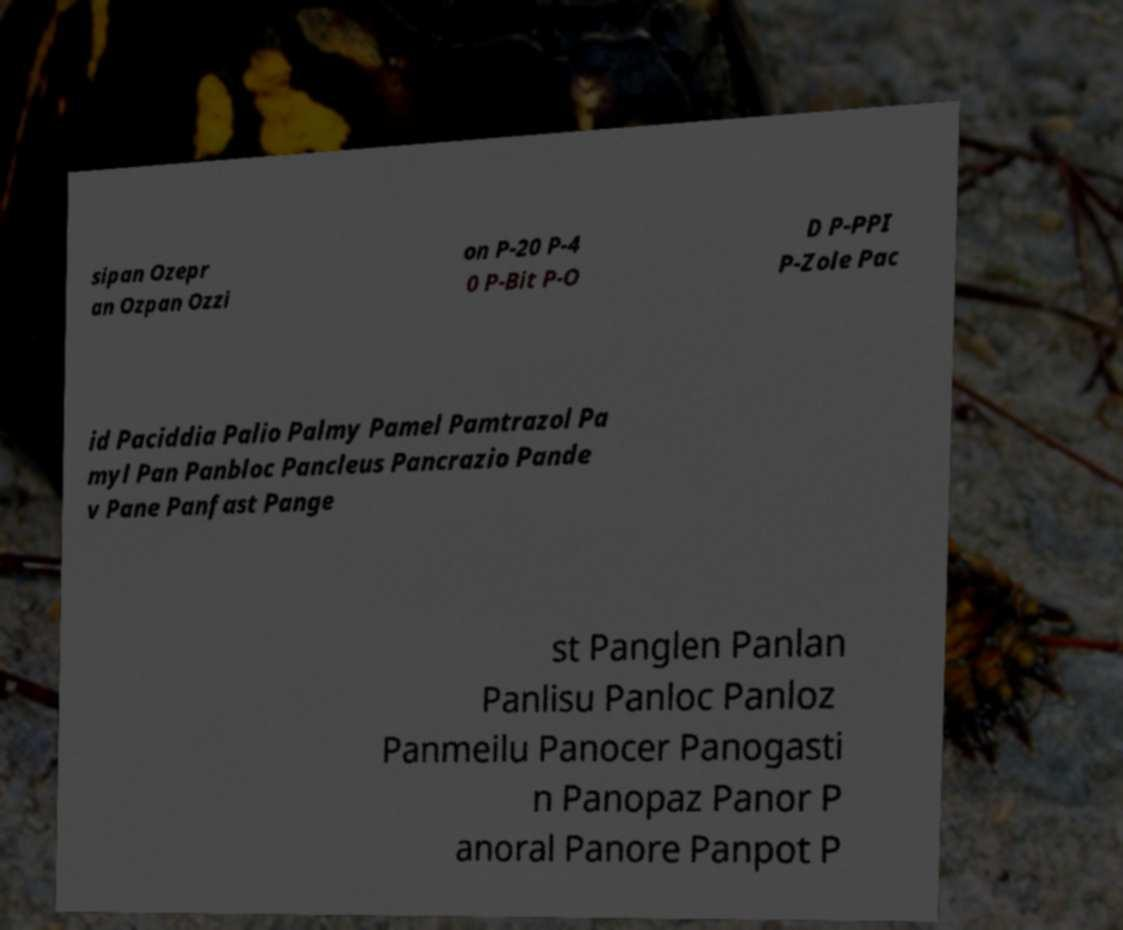Please identify and transcribe the text found in this image. sipan Ozepr an Ozpan Ozzi on P-20 P-4 0 P-Bit P-O D P-PPI P-Zole Pac id Paciddia Palio Palmy Pamel Pamtrazol Pa myl Pan Panbloc Pancleus Pancrazio Pande v Pane Panfast Pange st Panglen Panlan Panlisu Panloc Panloz Panmeilu Panocer Panogasti n Panopaz Panor P anoral Panore Panpot P 